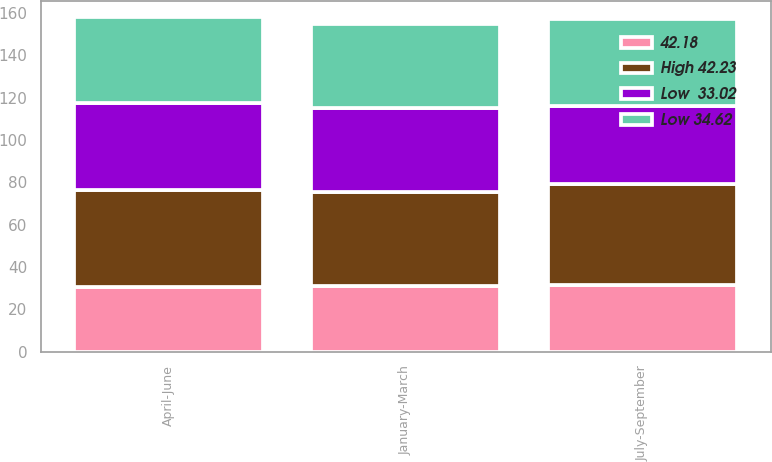<chart> <loc_0><loc_0><loc_500><loc_500><stacked_bar_chart><ecel><fcel>January-March<fcel>April-June<fcel>July-September<nl><fcel>High 42.23<fcel>44.35<fcel>45.6<fcel>47.65<nl><fcel>Low 34.62<fcel>39.38<fcel>40.48<fcel>40.95<nl><fcel>Low  33.02<fcel>39.94<fcel>41.24<fcel>36.99<nl><fcel>42.18<fcel>31<fcel>30.56<fcel>31.59<nl></chart> 